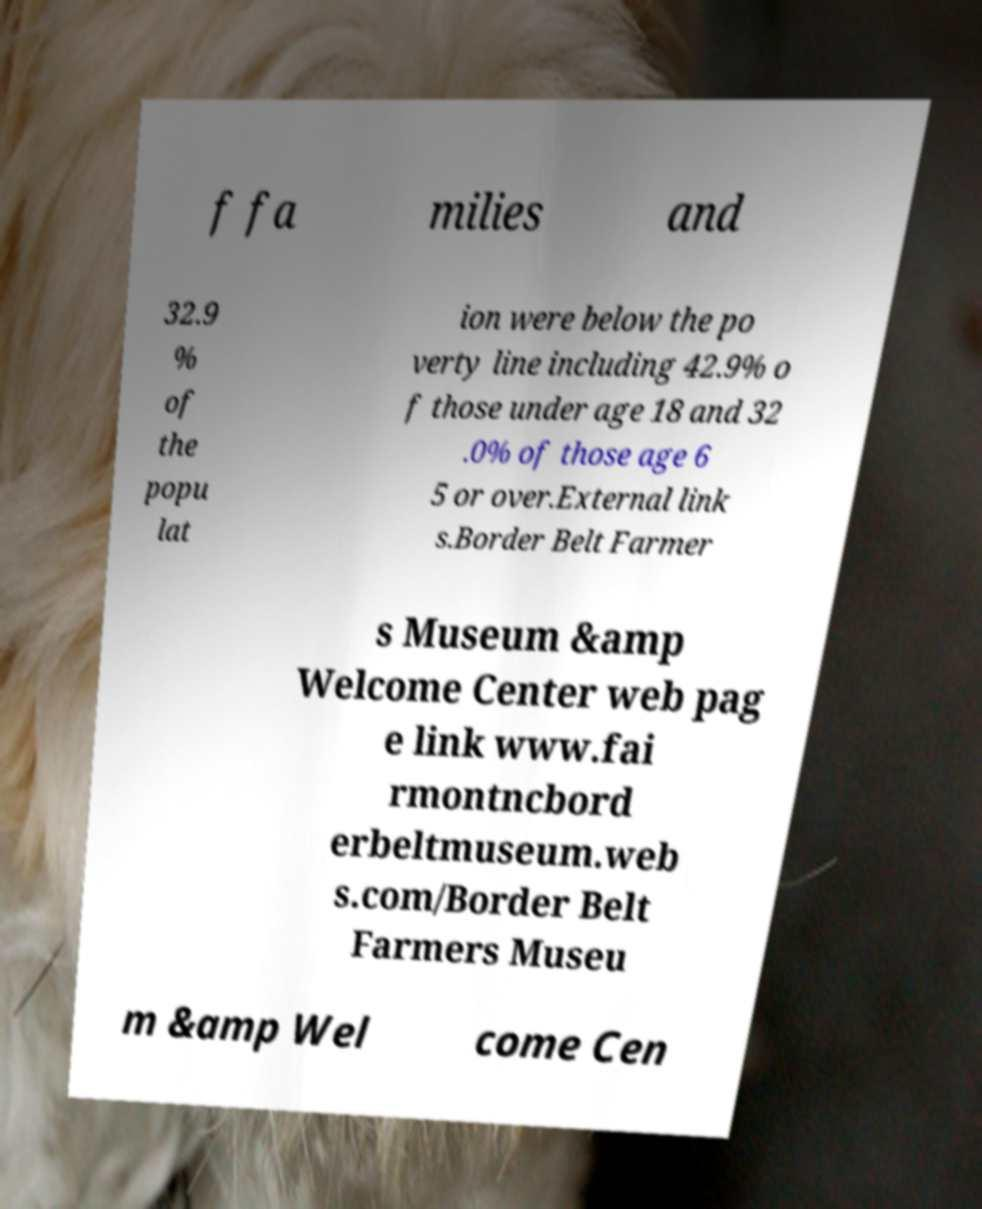Please read and relay the text visible in this image. What does it say? f fa milies and 32.9 % of the popu lat ion were below the po verty line including 42.9% o f those under age 18 and 32 .0% of those age 6 5 or over.External link s.Border Belt Farmer s Museum &amp Welcome Center web pag e link www.fai rmontncbord erbeltmuseum.web s.com/Border Belt Farmers Museu m &amp Wel come Cen 